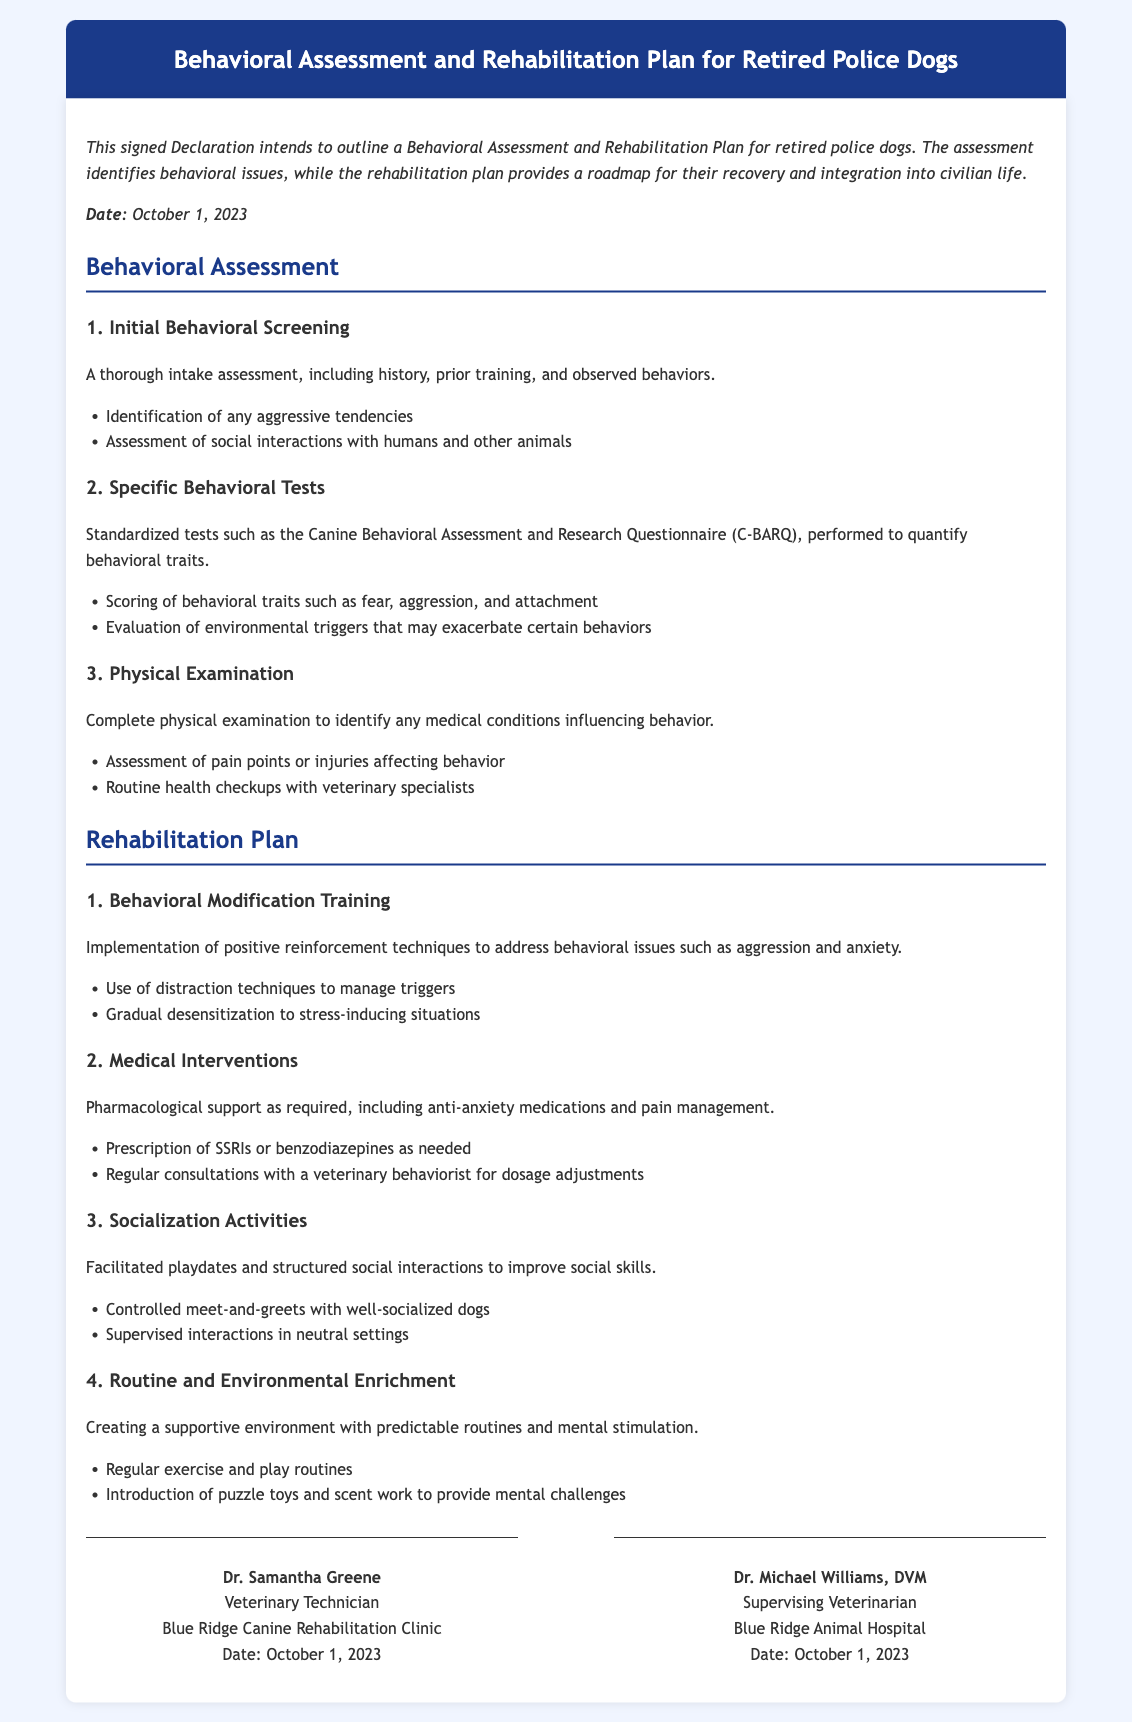What is the date of the Declaration? The Declaration states that it was created on October 1, 2023.
Answer: October 1, 2023 Who is the supervising veterinarian? The document identifies Dr. Michael Williams as the supervising veterinarian.
Answer: Dr. Michael Williams, DVM What is one of the behavioral issues identified in the behavioral assessment? The assessment mentions aggressive tendencies as a potential behavioral issue.
Answer: Aggression What type of training is included in the rehabilitation plan? The rehabilitation plan specifies behavioral modification training.
Answer: Behavioral modification training What medication types are mentioned for medical interventions? The document lists SSRIs and benzodiazepines under medical interventions.
Answer: SSRIs or benzodiazepines What is one activity listed for socialization? The rehabilitation plan includes controlled meet-and-greets with well-socialized dogs.
Answer: Controlled meet-and-greets How many sections are there in the behavioral assessment? The behavioral assessment has three sections outlined in the document.
Answer: Three Who signed the Declaration? Dr. Samantha Greene and Dr. Michael Williams signed the document.
Answer: Dr. Samantha Greene and Dr. Michael Williams 